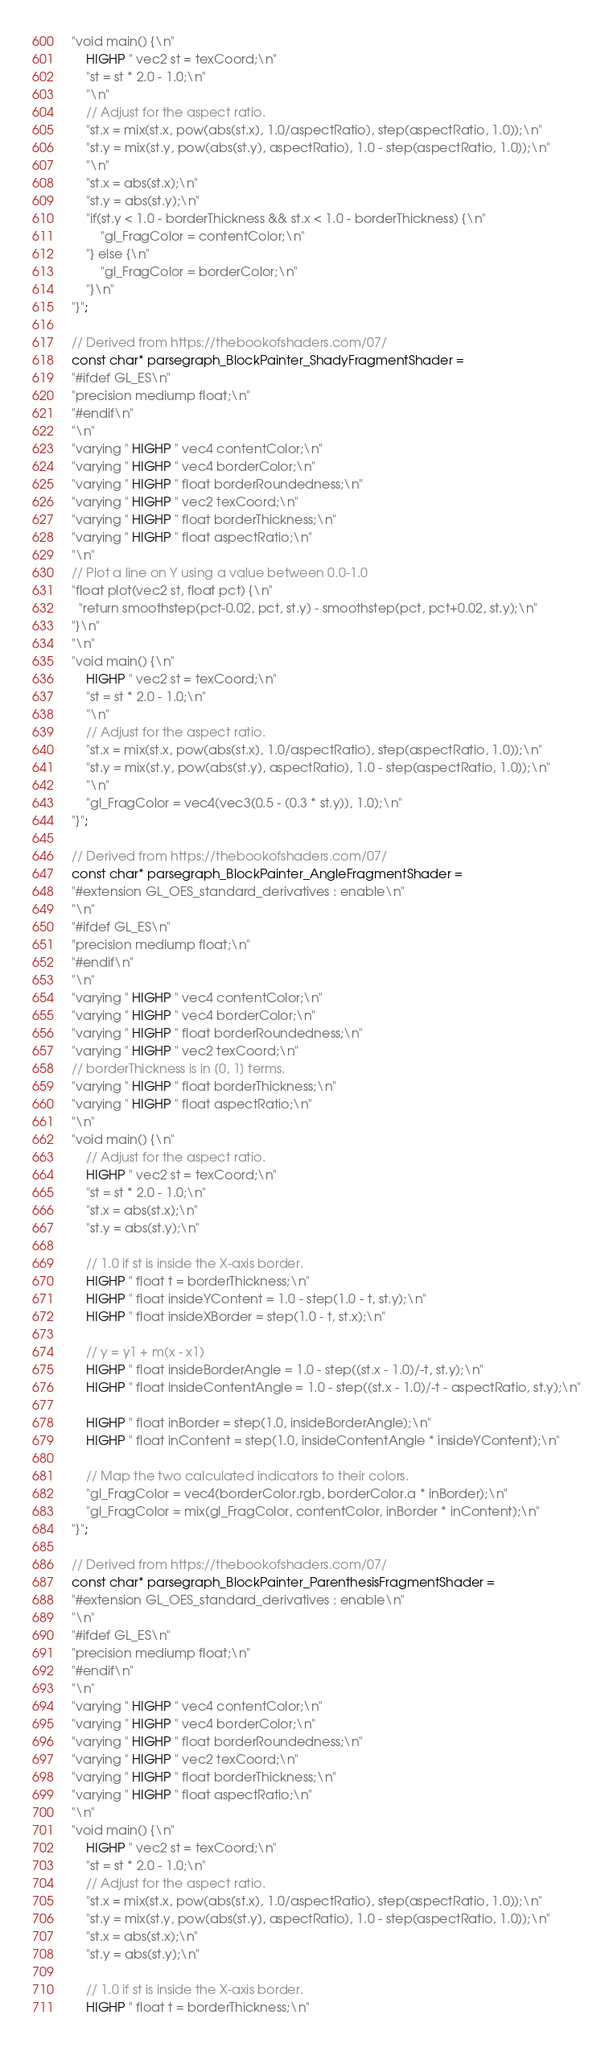<code> <loc_0><loc_0><loc_500><loc_500><_C_>"void main() {\n"
    HIGHP " vec2 st = texCoord;\n"
    "st = st * 2.0 - 1.0;\n"
    "\n"
    // Adjust for the aspect ratio.
    "st.x = mix(st.x, pow(abs(st.x), 1.0/aspectRatio), step(aspectRatio, 1.0));\n"
    "st.y = mix(st.y, pow(abs(st.y), aspectRatio), 1.0 - step(aspectRatio, 1.0));\n"
    "\n"
    "st.x = abs(st.x);\n"
    "st.y = abs(st.y);\n"
    "if(st.y < 1.0 - borderThickness && st.x < 1.0 - borderThickness) {\n"
        "gl_FragColor = contentColor;\n"
    "} else {\n"
        "gl_FragColor = borderColor;\n"
    "}\n"
"}";

// Derived from https://thebookofshaders.com/07/
const char* parsegraph_BlockPainter_ShadyFragmentShader =
"#ifdef GL_ES\n"
"precision mediump float;\n"
"#endif\n"
"\n"
"varying " HIGHP " vec4 contentColor;\n"
"varying " HIGHP " vec4 borderColor;\n"
"varying " HIGHP " float borderRoundedness;\n"
"varying " HIGHP " vec2 texCoord;\n"
"varying " HIGHP " float borderThickness;\n"
"varying " HIGHP " float aspectRatio;\n"
"\n"
// Plot a line on Y using a value between 0.0-1.0
"float plot(vec2 st, float pct) {\n"
  "return smoothstep(pct-0.02, pct, st.y) - smoothstep(pct, pct+0.02, st.y);\n"
"}\n"
"\n"
"void main() {\n"
    HIGHP " vec2 st = texCoord;\n"
    "st = st * 2.0 - 1.0;\n"
    "\n"
    // Adjust for the aspect ratio.
    "st.x = mix(st.x, pow(abs(st.x), 1.0/aspectRatio), step(aspectRatio, 1.0));\n"
    "st.y = mix(st.y, pow(abs(st.y), aspectRatio), 1.0 - step(aspectRatio, 1.0));\n"
    "\n"
    "gl_FragColor = vec4(vec3(0.5 - (0.3 * st.y)), 1.0);\n"
"}";

// Derived from https://thebookofshaders.com/07/
const char* parsegraph_BlockPainter_AngleFragmentShader =
"#extension GL_OES_standard_derivatives : enable\n"
"\n"
"#ifdef GL_ES\n"
"precision mediump float;\n"
"#endif\n"
"\n"
"varying " HIGHP " vec4 contentColor;\n"
"varying " HIGHP " vec4 borderColor;\n"
"varying " HIGHP " float borderRoundedness;\n"
"varying " HIGHP " vec2 texCoord;\n"
// borderThickness is in [0, 1] terms.
"varying " HIGHP " float borderThickness;\n"
"varying " HIGHP " float aspectRatio;\n"
"\n"
"void main() {\n"
    // Adjust for the aspect ratio.
    HIGHP " vec2 st = texCoord;\n"
    "st = st * 2.0 - 1.0;\n"
    "st.x = abs(st.x);\n"
    "st.y = abs(st.y);\n"

    // 1.0 if st is inside the X-axis border.
    HIGHP " float t = borderThickness;\n"
    HIGHP " float insideYContent = 1.0 - step(1.0 - t, st.y);\n"
    HIGHP " float insideXBorder = step(1.0 - t, st.x);\n"

    // y = y1 + m(x - x1)
    HIGHP " float insideBorderAngle = 1.0 - step((st.x - 1.0)/-t, st.y);\n"
    HIGHP " float insideContentAngle = 1.0 - step((st.x - 1.0)/-t - aspectRatio, st.y);\n"

    HIGHP " float inBorder = step(1.0, insideBorderAngle);\n"
    HIGHP " float inContent = step(1.0, insideContentAngle * insideYContent);\n"

    // Map the two calculated indicators to their colors.
    "gl_FragColor = vec4(borderColor.rgb, borderColor.a * inBorder);\n"
    "gl_FragColor = mix(gl_FragColor, contentColor, inBorder * inContent);\n"
"}";

// Derived from https://thebookofshaders.com/07/
const char* parsegraph_BlockPainter_ParenthesisFragmentShader =
"#extension GL_OES_standard_derivatives : enable\n"
"\n"
"#ifdef GL_ES\n"
"precision mediump float;\n"
"#endif\n"
"\n"
"varying " HIGHP " vec4 contentColor;\n"
"varying " HIGHP " vec4 borderColor;\n"
"varying " HIGHP " float borderRoundedness;\n"
"varying " HIGHP " vec2 texCoord;\n"
"varying " HIGHP " float borderThickness;\n"
"varying " HIGHP " float aspectRatio;\n"
"\n"
"void main() {\n"
    HIGHP " vec2 st = texCoord;\n"
    "st = st * 2.0 - 1.0;\n"
    // Adjust for the aspect ratio.
    "st.x = mix(st.x, pow(abs(st.x), 1.0/aspectRatio), step(aspectRatio, 1.0));\n"
    "st.y = mix(st.y, pow(abs(st.y), aspectRatio), 1.0 - step(aspectRatio, 1.0));\n"
    "st.x = abs(st.x);\n"
    "st.y = abs(st.y);\n"

    // 1.0 if st is inside the X-axis border.
    HIGHP " float t = borderThickness;\n"</code> 